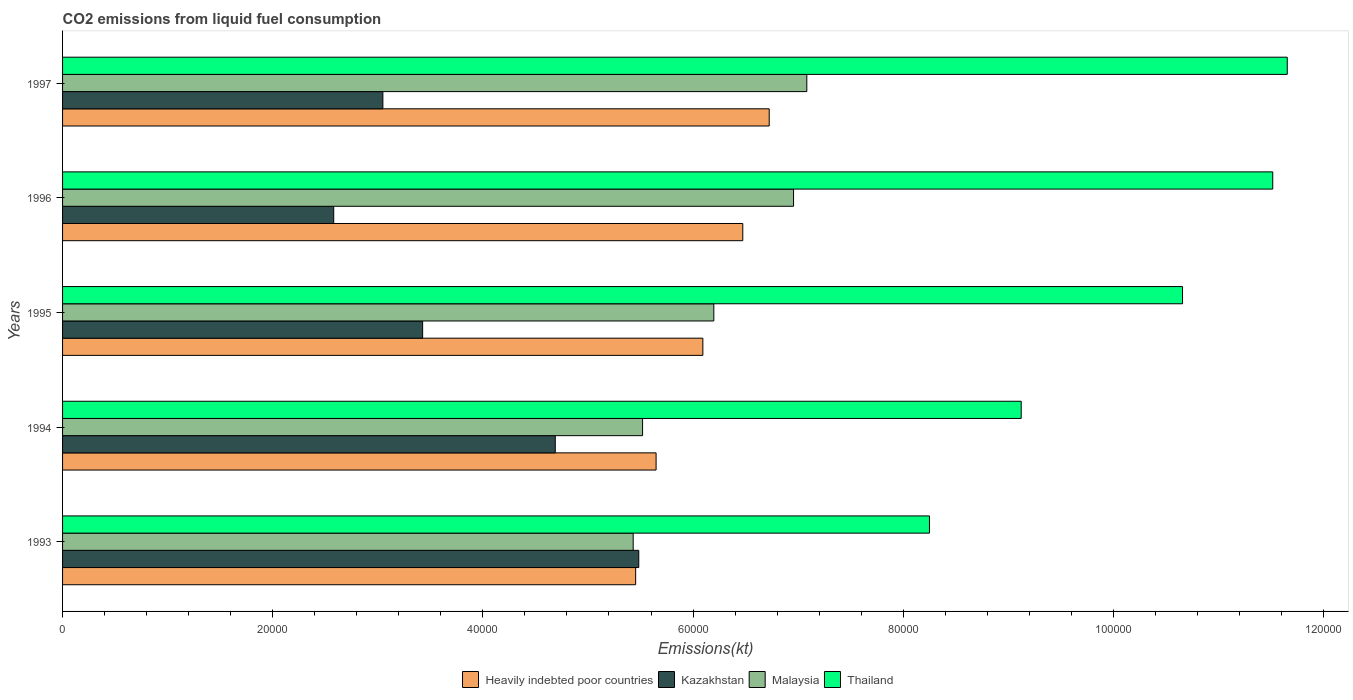How many different coloured bars are there?
Give a very brief answer. 4. Are the number of bars per tick equal to the number of legend labels?
Your answer should be very brief. Yes. Are the number of bars on each tick of the Y-axis equal?
Offer a very short reply. Yes. How many bars are there on the 2nd tick from the top?
Your answer should be very brief. 4. What is the label of the 2nd group of bars from the top?
Offer a very short reply. 1996. In how many cases, is the number of bars for a given year not equal to the number of legend labels?
Keep it short and to the point. 0. What is the amount of CO2 emitted in Heavily indebted poor countries in 1994?
Your answer should be very brief. 5.65e+04. Across all years, what is the maximum amount of CO2 emitted in Kazakhstan?
Give a very brief answer. 5.48e+04. Across all years, what is the minimum amount of CO2 emitted in Malaysia?
Offer a terse response. 5.43e+04. What is the total amount of CO2 emitted in Heavily indebted poor countries in the graph?
Provide a succinct answer. 3.04e+05. What is the difference between the amount of CO2 emitted in Kazakhstan in 1994 and that in 1997?
Offer a very short reply. 1.64e+04. What is the difference between the amount of CO2 emitted in Malaysia in 1996 and the amount of CO2 emitted in Thailand in 1997?
Give a very brief answer. -4.70e+04. What is the average amount of CO2 emitted in Heavily indebted poor countries per year?
Offer a terse response. 6.08e+04. In the year 1994, what is the difference between the amount of CO2 emitted in Heavily indebted poor countries and amount of CO2 emitted in Thailand?
Make the answer very short. -3.47e+04. What is the ratio of the amount of CO2 emitted in Heavily indebted poor countries in 1994 to that in 1997?
Make the answer very short. 0.84. Is the difference between the amount of CO2 emitted in Heavily indebted poor countries in 1993 and 1995 greater than the difference between the amount of CO2 emitted in Thailand in 1993 and 1995?
Provide a short and direct response. Yes. What is the difference between the highest and the second highest amount of CO2 emitted in Malaysia?
Offer a very short reply. 1261.45. What is the difference between the highest and the lowest amount of CO2 emitted in Kazakhstan?
Provide a short and direct response. 2.90e+04. In how many years, is the amount of CO2 emitted in Thailand greater than the average amount of CO2 emitted in Thailand taken over all years?
Keep it short and to the point. 3. What does the 4th bar from the top in 1997 represents?
Offer a very short reply. Heavily indebted poor countries. What does the 4th bar from the bottom in 1997 represents?
Your answer should be compact. Thailand. Are all the bars in the graph horizontal?
Make the answer very short. Yes. Does the graph contain any zero values?
Offer a terse response. No. Where does the legend appear in the graph?
Your answer should be very brief. Bottom center. How many legend labels are there?
Provide a short and direct response. 4. What is the title of the graph?
Give a very brief answer. CO2 emissions from liquid fuel consumption. What is the label or title of the X-axis?
Provide a succinct answer. Emissions(kt). What is the label or title of the Y-axis?
Keep it short and to the point. Years. What is the Emissions(kt) of Heavily indebted poor countries in 1993?
Your response must be concise. 5.45e+04. What is the Emissions(kt) of Kazakhstan in 1993?
Your answer should be compact. 5.48e+04. What is the Emissions(kt) of Malaysia in 1993?
Give a very brief answer. 5.43e+04. What is the Emissions(kt) in Thailand in 1993?
Make the answer very short. 8.25e+04. What is the Emissions(kt) of Heavily indebted poor countries in 1994?
Offer a terse response. 5.65e+04. What is the Emissions(kt) of Kazakhstan in 1994?
Ensure brevity in your answer.  4.69e+04. What is the Emissions(kt) of Malaysia in 1994?
Your answer should be very brief. 5.52e+04. What is the Emissions(kt) in Thailand in 1994?
Keep it short and to the point. 9.12e+04. What is the Emissions(kt) of Heavily indebted poor countries in 1995?
Your answer should be compact. 6.09e+04. What is the Emissions(kt) in Kazakhstan in 1995?
Offer a terse response. 3.43e+04. What is the Emissions(kt) of Malaysia in 1995?
Your answer should be compact. 6.20e+04. What is the Emissions(kt) in Thailand in 1995?
Provide a short and direct response. 1.07e+05. What is the Emissions(kt) in Heavily indebted poor countries in 1996?
Provide a succinct answer. 6.47e+04. What is the Emissions(kt) in Kazakhstan in 1996?
Give a very brief answer. 2.58e+04. What is the Emissions(kt) of Malaysia in 1996?
Make the answer very short. 6.96e+04. What is the Emissions(kt) in Thailand in 1996?
Your response must be concise. 1.15e+05. What is the Emissions(kt) in Heavily indebted poor countries in 1997?
Provide a succinct answer. 6.72e+04. What is the Emissions(kt) of Kazakhstan in 1997?
Your answer should be compact. 3.05e+04. What is the Emissions(kt) of Malaysia in 1997?
Provide a short and direct response. 7.08e+04. What is the Emissions(kt) of Thailand in 1997?
Offer a terse response. 1.17e+05. Across all years, what is the maximum Emissions(kt) in Heavily indebted poor countries?
Keep it short and to the point. 6.72e+04. Across all years, what is the maximum Emissions(kt) of Kazakhstan?
Keep it short and to the point. 5.48e+04. Across all years, what is the maximum Emissions(kt) of Malaysia?
Give a very brief answer. 7.08e+04. Across all years, what is the maximum Emissions(kt) in Thailand?
Offer a very short reply. 1.17e+05. Across all years, what is the minimum Emissions(kt) in Heavily indebted poor countries?
Make the answer very short. 5.45e+04. Across all years, what is the minimum Emissions(kt) in Kazakhstan?
Offer a very short reply. 2.58e+04. Across all years, what is the minimum Emissions(kt) in Malaysia?
Your response must be concise. 5.43e+04. Across all years, what is the minimum Emissions(kt) in Thailand?
Your answer should be very brief. 8.25e+04. What is the total Emissions(kt) of Heavily indebted poor countries in the graph?
Give a very brief answer. 3.04e+05. What is the total Emissions(kt) in Kazakhstan in the graph?
Provide a short and direct response. 1.92e+05. What is the total Emissions(kt) of Malaysia in the graph?
Your answer should be very brief. 3.12e+05. What is the total Emissions(kt) of Thailand in the graph?
Make the answer very short. 5.12e+05. What is the difference between the Emissions(kt) of Heavily indebted poor countries in 1993 and that in 1994?
Your response must be concise. -1944.04. What is the difference between the Emissions(kt) in Kazakhstan in 1993 and that in 1994?
Ensure brevity in your answer.  7946.39. What is the difference between the Emissions(kt) in Malaysia in 1993 and that in 1994?
Provide a short and direct response. -894.75. What is the difference between the Emissions(kt) in Thailand in 1993 and that in 1994?
Offer a terse response. -8731.13. What is the difference between the Emissions(kt) of Heavily indebted poor countries in 1993 and that in 1995?
Provide a succinct answer. -6394.79. What is the difference between the Emissions(kt) in Kazakhstan in 1993 and that in 1995?
Keep it short and to the point. 2.06e+04. What is the difference between the Emissions(kt) of Malaysia in 1993 and that in 1995?
Make the answer very short. -7675.03. What is the difference between the Emissions(kt) of Thailand in 1993 and that in 1995?
Provide a short and direct response. -2.41e+04. What is the difference between the Emissions(kt) in Heavily indebted poor countries in 1993 and that in 1996?
Offer a terse response. -1.02e+04. What is the difference between the Emissions(kt) in Kazakhstan in 1993 and that in 1996?
Keep it short and to the point. 2.90e+04. What is the difference between the Emissions(kt) in Malaysia in 1993 and that in 1996?
Make the answer very short. -1.53e+04. What is the difference between the Emissions(kt) in Thailand in 1993 and that in 1996?
Your response must be concise. -3.27e+04. What is the difference between the Emissions(kt) in Heavily indebted poor countries in 1993 and that in 1997?
Keep it short and to the point. -1.27e+04. What is the difference between the Emissions(kt) in Kazakhstan in 1993 and that in 1997?
Give a very brief answer. 2.44e+04. What is the difference between the Emissions(kt) in Malaysia in 1993 and that in 1997?
Keep it short and to the point. -1.65e+04. What is the difference between the Emissions(kt) of Thailand in 1993 and that in 1997?
Your response must be concise. -3.41e+04. What is the difference between the Emissions(kt) of Heavily indebted poor countries in 1994 and that in 1995?
Your answer should be very brief. -4450.75. What is the difference between the Emissions(kt) of Kazakhstan in 1994 and that in 1995?
Your answer should be very brief. 1.26e+04. What is the difference between the Emissions(kt) in Malaysia in 1994 and that in 1995?
Provide a short and direct response. -6780.28. What is the difference between the Emissions(kt) in Thailand in 1994 and that in 1995?
Provide a short and direct response. -1.54e+04. What is the difference between the Emissions(kt) of Heavily indebted poor countries in 1994 and that in 1996?
Your answer should be very brief. -8250.89. What is the difference between the Emissions(kt) in Kazakhstan in 1994 and that in 1996?
Your response must be concise. 2.11e+04. What is the difference between the Emissions(kt) of Malaysia in 1994 and that in 1996?
Give a very brief answer. -1.44e+04. What is the difference between the Emissions(kt) of Thailand in 1994 and that in 1996?
Keep it short and to the point. -2.39e+04. What is the difference between the Emissions(kt) in Heavily indebted poor countries in 1994 and that in 1997?
Offer a very short reply. -1.08e+04. What is the difference between the Emissions(kt) of Kazakhstan in 1994 and that in 1997?
Make the answer very short. 1.64e+04. What is the difference between the Emissions(kt) of Malaysia in 1994 and that in 1997?
Your answer should be very brief. -1.56e+04. What is the difference between the Emissions(kt) in Thailand in 1994 and that in 1997?
Provide a succinct answer. -2.53e+04. What is the difference between the Emissions(kt) of Heavily indebted poor countries in 1995 and that in 1996?
Provide a short and direct response. -3800.14. What is the difference between the Emissions(kt) of Kazakhstan in 1995 and that in 1996?
Offer a terse response. 8463.44. What is the difference between the Emissions(kt) in Malaysia in 1995 and that in 1996?
Keep it short and to the point. -7587.02. What is the difference between the Emissions(kt) in Thailand in 1995 and that in 1996?
Provide a succinct answer. -8584.45. What is the difference between the Emissions(kt) in Heavily indebted poor countries in 1995 and that in 1997?
Offer a very short reply. -6313.86. What is the difference between the Emissions(kt) in Kazakhstan in 1995 and that in 1997?
Provide a short and direct response. 3784.34. What is the difference between the Emissions(kt) in Malaysia in 1995 and that in 1997?
Make the answer very short. -8848.47. What is the difference between the Emissions(kt) in Thailand in 1995 and that in 1997?
Provide a short and direct response. -9966.91. What is the difference between the Emissions(kt) in Heavily indebted poor countries in 1996 and that in 1997?
Provide a succinct answer. -2513.71. What is the difference between the Emissions(kt) of Kazakhstan in 1996 and that in 1997?
Offer a terse response. -4679.09. What is the difference between the Emissions(kt) of Malaysia in 1996 and that in 1997?
Keep it short and to the point. -1261.45. What is the difference between the Emissions(kt) of Thailand in 1996 and that in 1997?
Provide a short and direct response. -1382.46. What is the difference between the Emissions(kt) in Heavily indebted poor countries in 1993 and the Emissions(kt) in Kazakhstan in 1994?
Keep it short and to the point. 7650.65. What is the difference between the Emissions(kt) in Heavily indebted poor countries in 1993 and the Emissions(kt) in Malaysia in 1994?
Offer a very short reply. -658.77. What is the difference between the Emissions(kt) in Heavily indebted poor countries in 1993 and the Emissions(kt) in Thailand in 1994?
Keep it short and to the point. -3.67e+04. What is the difference between the Emissions(kt) in Kazakhstan in 1993 and the Emissions(kt) in Malaysia in 1994?
Offer a very short reply. -363.03. What is the difference between the Emissions(kt) in Kazakhstan in 1993 and the Emissions(kt) in Thailand in 1994?
Keep it short and to the point. -3.64e+04. What is the difference between the Emissions(kt) in Malaysia in 1993 and the Emissions(kt) in Thailand in 1994?
Your answer should be very brief. -3.69e+04. What is the difference between the Emissions(kt) of Heavily indebted poor countries in 1993 and the Emissions(kt) of Kazakhstan in 1995?
Ensure brevity in your answer.  2.03e+04. What is the difference between the Emissions(kt) in Heavily indebted poor countries in 1993 and the Emissions(kt) in Malaysia in 1995?
Your answer should be compact. -7439.06. What is the difference between the Emissions(kt) of Heavily indebted poor countries in 1993 and the Emissions(kt) of Thailand in 1995?
Give a very brief answer. -5.20e+04. What is the difference between the Emissions(kt) in Kazakhstan in 1993 and the Emissions(kt) in Malaysia in 1995?
Provide a succinct answer. -7143.32. What is the difference between the Emissions(kt) of Kazakhstan in 1993 and the Emissions(kt) of Thailand in 1995?
Provide a short and direct response. -5.17e+04. What is the difference between the Emissions(kt) in Malaysia in 1993 and the Emissions(kt) in Thailand in 1995?
Provide a succinct answer. -5.23e+04. What is the difference between the Emissions(kt) in Heavily indebted poor countries in 1993 and the Emissions(kt) in Kazakhstan in 1996?
Provide a short and direct response. 2.87e+04. What is the difference between the Emissions(kt) in Heavily indebted poor countries in 1993 and the Emissions(kt) in Malaysia in 1996?
Provide a succinct answer. -1.50e+04. What is the difference between the Emissions(kt) of Heavily indebted poor countries in 1993 and the Emissions(kt) of Thailand in 1996?
Ensure brevity in your answer.  -6.06e+04. What is the difference between the Emissions(kt) of Kazakhstan in 1993 and the Emissions(kt) of Malaysia in 1996?
Give a very brief answer. -1.47e+04. What is the difference between the Emissions(kt) of Kazakhstan in 1993 and the Emissions(kt) of Thailand in 1996?
Your answer should be very brief. -6.03e+04. What is the difference between the Emissions(kt) of Malaysia in 1993 and the Emissions(kt) of Thailand in 1996?
Give a very brief answer. -6.09e+04. What is the difference between the Emissions(kt) in Heavily indebted poor countries in 1993 and the Emissions(kt) in Kazakhstan in 1997?
Give a very brief answer. 2.41e+04. What is the difference between the Emissions(kt) of Heavily indebted poor countries in 1993 and the Emissions(kt) of Malaysia in 1997?
Make the answer very short. -1.63e+04. What is the difference between the Emissions(kt) of Heavily indebted poor countries in 1993 and the Emissions(kt) of Thailand in 1997?
Ensure brevity in your answer.  -6.20e+04. What is the difference between the Emissions(kt) in Kazakhstan in 1993 and the Emissions(kt) in Malaysia in 1997?
Your answer should be compact. -1.60e+04. What is the difference between the Emissions(kt) of Kazakhstan in 1993 and the Emissions(kt) of Thailand in 1997?
Provide a succinct answer. -6.17e+04. What is the difference between the Emissions(kt) in Malaysia in 1993 and the Emissions(kt) in Thailand in 1997?
Your response must be concise. -6.22e+04. What is the difference between the Emissions(kt) in Heavily indebted poor countries in 1994 and the Emissions(kt) in Kazakhstan in 1995?
Provide a succinct answer. 2.22e+04. What is the difference between the Emissions(kt) in Heavily indebted poor countries in 1994 and the Emissions(kt) in Malaysia in 1995?
Make the answer very short. -5495.02. What is the difference between the Emissions(kt) in Heavily indebted poor countries in 1994 and the Emissions(kt) in Thailand in 1995?
Offer a very short reply. -5.01e+04. What is the difference between the Emissions(kt) in Kazakhstan in 1994 and the Emissions(kt) in Malaysia in 1995?
Provide a short and direct response. -1.51e+04. What is the difference between the Emissions(kt) of Kazakhstan in 1994 and the Emissions(kt) of Thailand in 1995?
Your response must be concise. -5.97e+04. What is the difference between the Emissions(kt) of Malaysia in 1994 and the Emissions(kt) of Thailand in 1995?
Your answer should be compact. -5.14e+04. What is the difference between the Emissions(kt) of Heavily indebted poor countries in 1994 and the Emissions(kt) of Kazakhstan in 1996?
Keep it short and to the point. 3.07e+04. What is the difference between the Emissions(kt) in Heavily indebted poor countries in 1994 and the Emissions(kt) in Malaysia in 1996?
Keep it short and to the point. -1.31e+04. What is the difference between the Emissions(kt) in Heavily indebted poor countries in 1994 and the Emissions(kt) in Thailand in 1996?
Provide a short and direct response. -5.87e+04. What is the difference between the Emissions(kt) of Kazakhstan in 1994 and the Emissions(kt) of Malaysia in 1996?
Provide a succinct answer. -2.27e+04. What is the difference between the Emissions(kt) of Kazakhstan in 1994 and the Emissions(kt) of Thailand in 1996?
Offer a terse response. -6.83e+04. What is the difference between the Emissions(kt) in Malaysia in 1994 and the Emissions(kt) in Thailand in 1996?
Offer a very short reply. -6.00e+04. What is the difference between the Emissions(kt) of Heavily indebted poor countries in 1994 and the Emissions(kt) of Kazakhstan in 1997?
Provide a short and direct response. 2.60e+04. What is the difference between the Emissions(kt) in Heavily indebted poor countries in 1994 and the Emissions(kt) in Malaysia in 1997?
Give a very brief answer. -1.43e+04. What is the difference between the Emissions(kt) in Heavily indebted poor countries in 1994 and the Emissions(kt) in Thailand in 1997?
Provide a short and direct response. -6.01e+04. What is the difference between the Emissions(kt) of Kazakhstan in 1994 and the Emissions(kt) of Malaysia in 1997?
Offer a very short reply. -2.39e+04. What is the difference between the Emissions(kt) in Kazakhstan in 1994 and the Emissions(kt) in Thailand in 1997?
Offer a very short reply. -6.97e+04. What is the difference between the Emissions(kt) in Malaysia in 1994 and the Emissions(kt) in Thailand in 1997?
Provide a short and direct response. -6.14e+04. What is the difference between the Emissions(kt) in Heavily indebted poor countries in 1995 and the Emissions(kt) in Kazakhstan in 1996?
Provide a short and direct response. 3.51e+04. What is the difference between the Emissions(kt) of Heavily indebted poor countries in 1995 and the Emissions(kt) of Malaysia in 1996?
Ensure brevity in your answer.  -8631.29. What is the difference between the Emissions(kt) in Heavily indebted poor countries in 1995 and the Emissions(kt) in Thailand in 1996?
Your answer should be compact. -5.42e+04. What is the difference between the Emissions(kt) in Kazakhstan in 1995 and the Emissions(kt) in Malaysia in 1996?
Ensure brevity in your answer.  -3.53e+04. What is the difference between the Emissions(kt) of Kazakhstan in 1995 and the Emissions(kt) of Thailand in 1996?
Offer a terse response. -8.09e+04. What is the difference between the Emissions(kt) of Malaysia in 1995 and the Emissions(kt) of Thailand in 1996?
Your response must be concise. -5.32e+04. What is the difference between the Emissions(kt) in Heavily indebted poor countries in 1995 and the Emissions(kt) in Kazakhstan in 1997?
Provide a succinct answer. 3.05e+04. What is the difference between the Emissions(kt) in Heavily indebted poor countries in 1995 and the Emissions(kt) in Malaysia in 1997?
Keep it short and to the point. -9892.74. What is the difference between the Emissions(kt) of Heavily indebted poor countries in 1995 and the Emissions(kt) of Thailand in 1997?
Your answer should be very brief. -5.56e+04. What is the difference between the Emissions(kt) of Kazakhstan in 1995 and the Emissions(kt) of Malaysia in 1997?
Your answer should be compact. -3.66e+04. What is the difference between the Emissions(kt) of Kazakhstan in 1995 and the Emissions(kt) of Thailand in 1997?
Make the answer very short. -8.23e+04. What is the difference between the Emissions(kt) in Malaysia in 1995 and the Emissions(kt) in Thailand in 1997?
Your response must be concise. -5.46e+04. What is the difference between the Emissions(kt) in Heavily indebted poor countries in 1996 and the Emissions(kt) in Kazakhstan in 1997?
Keep it short and to the point. 3.43e+04. What is the difference between the Emissions(kt) of Heavily indebted poor countries in 1996 and the Emissions(kt) of Malaysia in 1997?
Keep it short and to the point. -6092.6. What is the difference between the Emissions(kt) of Heavily indebted poor countries in 1996 and the Emissions(kt) of Thailand in 1997?
Your response must be concise. -5.18e+04. What is the difference between the Emissions(kt) in Kazakhstan in 1996 and the Emissions(kt) in Malaysia in 1997?
Your response must be concise. -4.50e+04. What is the difference between the Emissions(kt) in Kazakhstan in 1996 and the Emissions(kt) in Thailand in 1997?
Make the answer very short. -9.07e+04. What is the difference between the Emissions(kt) of Malaysia in 1996 and the Emissions(kt) of Thailand in 1997?
Offer a very short reply. -4.70e+04. What is the average Emissions(kt) in Heavily indebted poor countries per year?
Provide a short and direct response. 6.08e+04. What is the average Emissions(kt) of Kazakhstan per year?
Give a very brief answer. 3.85e+04. What is the average Emissions(kt) of Malaysia per year?
Your response must be concise. 6.24e+04. What is the average Emissions(kt) in Thailand per year?
Your answer should be compact. 1.02e+05. In the year 1993, what is the difference between the Emissions(kt) of Heavily indebted poor countries and Emissions(kt) of Kazakhstan?
Your response must be concise. -295.74. In the year 1993, what is the difference between the Emissions(kt) of Heavily indebted poor countries and Emissions(kt) of Malaysia?
Ensure brevity in your answer.  235.97. In the year 1993, what is the difference between the Emissions(kt) in Heavily indebted poor countries and Emissions(kt) in Thailand?
Your answer should be compact. -2.80e+04. In the year 1993, what is the difference between the Emissions(kt) of Kazakhstan and Emissions(kt) of Malaysia?
Ensure brevity in your answer.  531.72. In the year 1993, what is the difference between the Emissions(kt) of Kazakhstan and Emissions(kt) of Thailand?
Offer a very short reply. -2.77e+04. In the year 1993, what is the difference between the Emissions(kt) in Malaysia and Emissions(kt) in Thailand?
Offer a very short reply. -2.82e+04. In the year 1994, what is the difference between the Emissions(kt) in Heavily indebted poor countries and Emissions(kt) in Kazakhstan?
Your answer should be compact. 9594.68. In the year 1994, what is the difference between the Emissions(kt) in Heavily indebted poor countries and Emissions(kt) in Malaysia?
Your answer should be compact. 1285.26. In the year 1994, what is the difference between the Emissions(kt) in Heavily indebted poor countries and Emissions(kt) in Thailand?
Offer a very short reply. -3.47e+04. In the year 1994, what is the difference between the Emissions(kt) in Kazakhstan and Emissions(kt) in Malaysia?
Provide a succinct answer. -8309.42. In the year 1994, what is the difference between the Emissions(kt) of Kazakhstan and Emissions(kt) of Thailand?
Provide a succinct answer. -4.43e+04. In the year 1994, what is the difference between the Emissions(kt) in Malaysia and Emissions(kt) in Thailand?
Your answer should be very brief. -3.60e+04. In the year 1995, what is the difference between the Emissions(kt) in Heavily indebted poor countries and Emissions(kt) in Kazakhstan?
Provide a succinct answer. 2.67e+04. In the year 1995, what is the difference between the Emissions(kt) of Heavily indebted poor countries and Emissions(kt) of Malaysia?
Your answer should be very brief. -1044.27. In the year 1995, what is the difference between the Emissions(kt) of Heavily indebted poor countries and Emissions(kt) of Thailand?
Offer a very short reply. -4.56e+04. In the year 1995, what is the difference between the Emissions(kt) in Kazakhstan and Emissions(kt) in Malaysia?
Keep it short and to the point. -2.77e+04. In the year 1995, what is the difference between the Emissions(kt) in Kazakhstan and Emissions(kt) in Thailand?
Offer a very short reply. -7.23e+04. In the year 1995, what is the difference between the Emissions(kt) in Malaysia and Emissions(kt) in Thailand?
Your answer should be very brief. -4.46e+04. In the year 1996, what is the difference between the Emissions(kt) of Heavily indebted poor countries and Emissions(kt) of Kazakhstan?
Offer a terse response. 3.89e+04. In the year 1996, what is the difference between the Emissions(kt) in Heavily indebted poor countries and Emissions(kt) in Malaysia?
Give a very brief answer. -4831.15. In the year 1996, what is the difference between the Emissions(kt) in Heavily indebted poor countries and Emissions(kt) in Thailand?
Make the answer very short. -5.04e+04. In the year 1996, what is the difference between the Emissions(kt) in Kazakhstan and Emissions(kt) in Malaysia?
Offer a terse response. -4.38e+04. In the year 1996, what is the difference between the Emissions(kt) in Kazakhstan and Emissions(kt) in Thailand?
Keep it short and to the point. -8.94e+04. In the year 1996, what is the difference between the Emissions(kt) in Malaysia and Emissions(kt) in Thailand?
Provide a succinct answer. -4.56e+04. In the year 1997, what is the difference between the Emissions(kt) in Heavily indebted poor countries and Emissions(kt) in Kazakhstan?
Provide a short and direct response. 3.68e+04. In the year 1997, what is the difference between the Emissions(kt) in Heavily indebted poor countries and Emissions(kt) in Malaysia?
Provide a succinct answer. -3578.88. In the year 1997, what is the difference between the Emissions(kt) of Heavily indebted poor countries and Emissions(kt) of Thailand?
Offer a very short reply. -4.93e+04. In the year 1997, what is the difference between the Emissions(kt) of Kazakhstan and Emissions(kt) of Malaysia?
Make the answer very short. -4.03e+04. In the year 1997, what is the difference between the Emissions(kt) of Kazakhstan and Emissions(kt) of Thailand?
Give a very brief answer. -8.61e+04. In the year 1997, what is the difference between the Emissions(kt) of Malaysia and Emissions(kt) of Thailand?
Keep it short and to the point. -4.57e+04. What is the ratio of the Emissions(kt) in Heavily indebted poor countries in 1993 to that in 1994?
Provide a short and direct response. 0.97. What is the ratio of the Emissions(kt) in Kazakhstan in 1993 to that in 1994?
Offer a terse response. 1.17. What is the ratio of the Emissions(kt) in Malaysia in 1993 to that in 1994?
Your response must be concise. 0.98. What is the ratio of the Emissions(kt) in Thailand in 1993 to that in 1994?
Ensure brevity in your answer.  0.9. What is the ratio of the Emissions(kt) of Heavily indebted poor countries in 1993 to that in 1995?
Ensure brevity in your answer.  0.9. What is the ratio of the Emissions(kt) of Kazakhstan in 1993 to that in 1995?
Your answer should be very brief. 1.6. What is the ratio of the Emissions(kt) in Malaysia in 1993 to that in 1995?
Provide a short and direct response. 0.88. What is the ratio of the Emissions(kt) in Thailand in 1993 to that in 1995?
Your answer should be compact. 0.77. What is the ratio of the Emissions(kt) of Heavily indebted poor countries in 1993 to that in 1996?
Ensure brevity in your answer.  0.84. What is the ratio of the Emissions(kt) in Kazakhstan in 1993 to that in 1996?
Give a very brief answer. 2.13. What is the ratio of the Emissions(kt) of Malaysia in 1993 to that in 1996?
Ensure brevity in your answer.  0.78. What is the ratio of the Emissions(kt) in Thailand in 1993 to that in 1996?
Provide a short and direct response. 0.72. What is the ratio of the Emissions(kt) of Heavily indebted poor countries in 1993 to that in 1997?
Keep it short and to the point. 0.81. What is the ratio of the Emissions(kt) of Kazakhstan in 1993 to that in 1997?
Provide a succinct answer. 1.8. What is the ratio of the Emissions(kt) in Malaysia in 1993 to that in 1997?
Give a very brief answer. 0.77. What is the ratio of the Emissions(kt) of Thailand in 1993 to that in 1997?
Make the answer very short. 0.71. What is the ratio of the Emissions(kt) of Heavily indebted poor countries in 1994 to that in 1995?
Ensure brevity in your answer.  0.93. What is the ratio of the Emissions(kt) in Kazakhstan in 1994 to that in 1995?
Provide a succinct answer. 1.37. What is the ratio of the Emissions(kt) in Malaysia in 1994 to that in 1995?
Provide a succinct answer. 0.89. What is the ratio of the Emissions(kt) in Thailand in 1994 to that in 1995?
Your answer should be very brief. 0.86. What is the ratio of the Emissions(kt) of Heavily indebted poor countries in 1994 to that in 1996?
Give a very brief answer. 0.87. What is the ratio of the Emissions(kt) of Kazakhstan in 1994 to that in 1996?
Ensure brevity in your answer.  1.82. What is the ratio of the Emissions(kt) of Malaysia in 1994 to that in 1996?
Your response must be concise. 0.79. What is the ratio of the Emissions(kt) in Thailand in 1994 to that in 1996?
Keep it short and to the point. 0.79. What is the ratio of the Emissions(kt) of Heavily indebted poor countries in 1994 to that in 1997?
Keep it short and to the point. 0.84. What is the ratio of the Emissions(kt) in Kazakhstan in 1994 to that in 1997?
Provide a short and direct response. 1.54. What is the ratio of the Emissions(kt) in Malaysia in 1994 to that in 1997?
Make the answer very short. 0.78. What is the ratio of the Emissions(kt) in Thailand in 1994 to that in 1997?
Your answer should be compact. 0.78. What is the ratio of the Emissions(kt) of Heavily indebted poor countries in 1995 to that in 1996?
Your response must be concise. 0.94. What is the ratio of the Emissions(kt) in Kazakhstan in 1995 to that in 1996?
Make the answer very short. 1.33. What is the ratio of the Emissions(kt) of Malaysia in 1995 to that in 1996?
Keep it short and to the point. 0.89. What is the ratio of the Emissions(kt) in Thailand in 1995 to that in 1996?
Provide a succinct answer. 0.93. What is the ratio of the Emissions(kt) in Heavily indebted poor countries in 1995 to that in 1997?
Your answer should be very brief. 0.91. What is the ratio of the Emissions(kt) of Kazakhstan in 1995 to that in 1997?
Offer a terse response. 1.12. What is the ratio of the Emissions(kt) of Malaysia in 1995 to that in 1997?
Your response must be concise. 0.88. What is the ratio of the Emissions(kt) in Thailand in 1995 to that in 1997?
Your answer should be very brief. 0.91. What is the ratio of the Emissions(kt) of Heavily indebted poor countries in 1996 to that in 1997?
Ensure brevity in your answer.  0.96. What is the ratio of the Emissions(kt) of Kazakhstan in 1996 to that in 1997?
Provide a succinct answer. 0.85. What is the ratio of the Emissions(kt) of Malaysia in 1996 to that in 1997?
Offer a terse response. 0.98. What is the ratio of the Emissions(kt) of Thailand in 1996 to that in 1997?
Your response must be concise. 0.99. What is the difference between the highest and the second highest Emissions(kt) of Heavily indebted poor countries?
Your answer should be very brief. 2513.71. What is the difference between the highest and the second highest Emissions(kt) in Kazakhstan?
Offer a terse response. 7946.39. What is the difference between the highest and the second highest Emissions(kt) of Malaysia?
Your response must be concise. 1261.45. What is the difference between the highest and the second highest Emissions(kt) in Thailand?
Provide a succinct answer. 1382.46. What is the difference between the highest and the lowest Emissions(kt) in Heavily indebted poor countries?
Your response must be concise. 1.27e+04. What is the difference between the highest and the lowest Emissions(kt) in Kazakhstan?
Your answer should be compact. 2.90e+04. What is the difference between the highest and the lowest Emissions(kt) of Malaysia?
Your answer should be very brief. 1.65e+04. What is the difference between the highest and the lowest Emissions(kt) of Thailand?
Your answer should be very brief. 3.41e+04. 